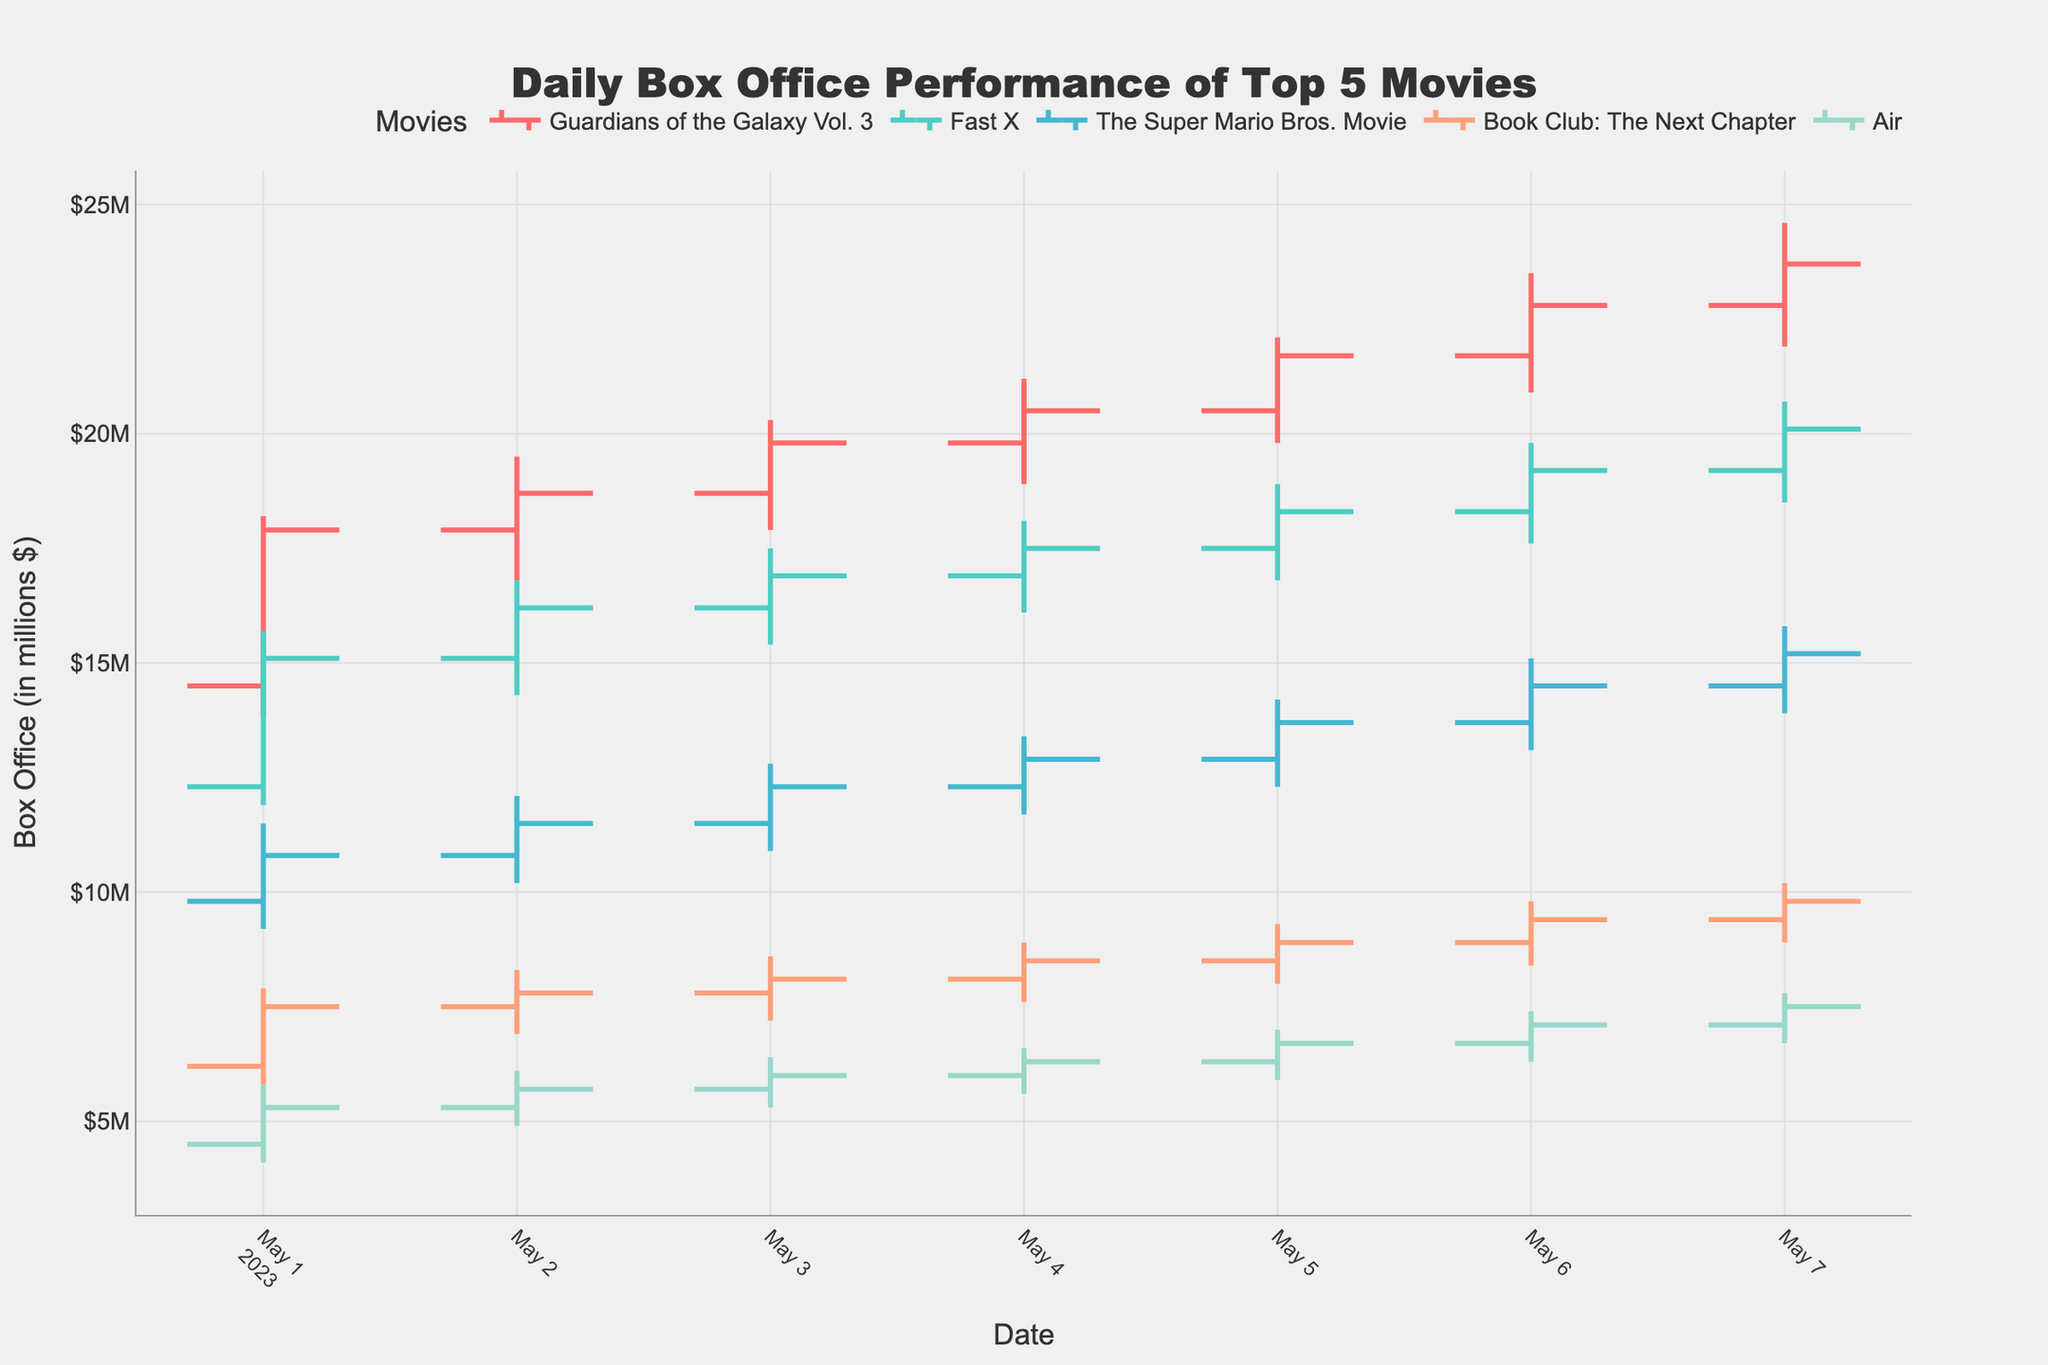which movie had the highest close value on May 1st? Look at the close values for each movie on May 1st. "Guardians of the Galaxy Vol. 3" had the highest close value of 17.9.
Answer: Guardians of the Galaxy Vol. 3 how did the daily box office performance of "Air" change from May 2nd to May 3rd? On May 2nd, the close value for "Air" was 5.7, and it increased to 6.0 on May 3rd, indicating an improvement in performance.
Answer: increased which day showed the highest volatility for "Fast X" in terms of the range between high and low values? Volatility can be seen by the difference between the high and low values each day. On May 2nd, the range for "Fast X" was 16.8 - 14.3 = 2.5, which was the highest during the week.
Answer: May 2nd what was the trend in box office performance for "Book Club: The Next Chapter" over the week? Observing the close values for each day, the values were 7.5, 7.8, 8.1, 8.5, 8.9, 9.4, 9.8, showing an overall upward trend.
Answer: upward between "The Super Mario Bros. Movie" and "Guardians of the Galaxy Vol. 3", which one had a higher average close value over the week? Calculate the average close value for both movies. "The Super Mario Bros. Movie": (10.8 + 11.5 + 12.3 + 12.9 + 13.7 + 14.5 + 15.2) / 7 = 12.7. "Guardians of the Galaxy Vol. 3": (17.9 + 18.7 + 19.8 + 20.5 + 21.7 + 22.8 + 23.7) / 7 = 20.7. "Guardians of the Galaxy Vol. 3" had a higher average value.
Answer: Guardians of the Galaxy Vol. 3 on which day did "The Super Mario Bros. Movie" have its lowest price? Review the low values for "The Super Mario Bros. Movie" throughout the week. The minimum low value was 9.2 on May 1st.
Answer: May 1st what was the highest closing value for "Fast X" during the week? Check the closing values for each day for "Fast X". The highest closing value was 20.1 on May 7th.
Answer: 20.1 what is the difference between the highest high value and the lowest low value for "Guardians of the Galaxy Vol. 3" during the week? The highest high value for "Guardians of the Galaxy Vol. 3" is 24.6 and the lowest low value is 13.8. The difference is 24.6 - 13.8 = 10.8.
Answer: 10.8 what trend can be observed in the daily box office performance of "Fast X" over the week? By observing the close values, "Fast X" started at 15.1 and gradually increased to 20.1 by the end of the week, indicating an upward trend.
Answer: upward which movie experienced the least volatility on May 6th? Check the range (high - low) for each movie. "Air" had the least range of 7.4 - 6.3 = 1.1, the smallest on May 6th.
Answer: Air 